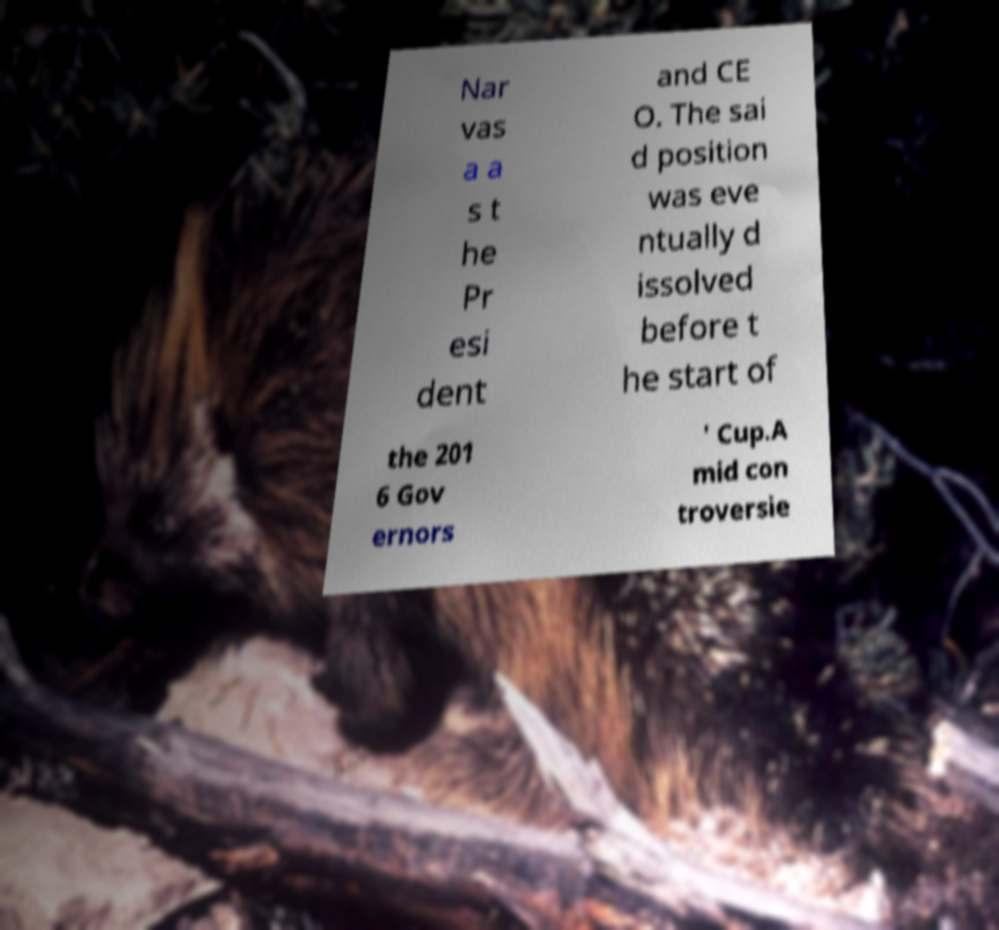Could you extract and type out the text from this image? Nar vas a a s t he Pr esi dent and CE O. The sai d position was eve ntually d issolved before t he start of the 201 6 Gov ernors ' Cup.A mid con troversie 